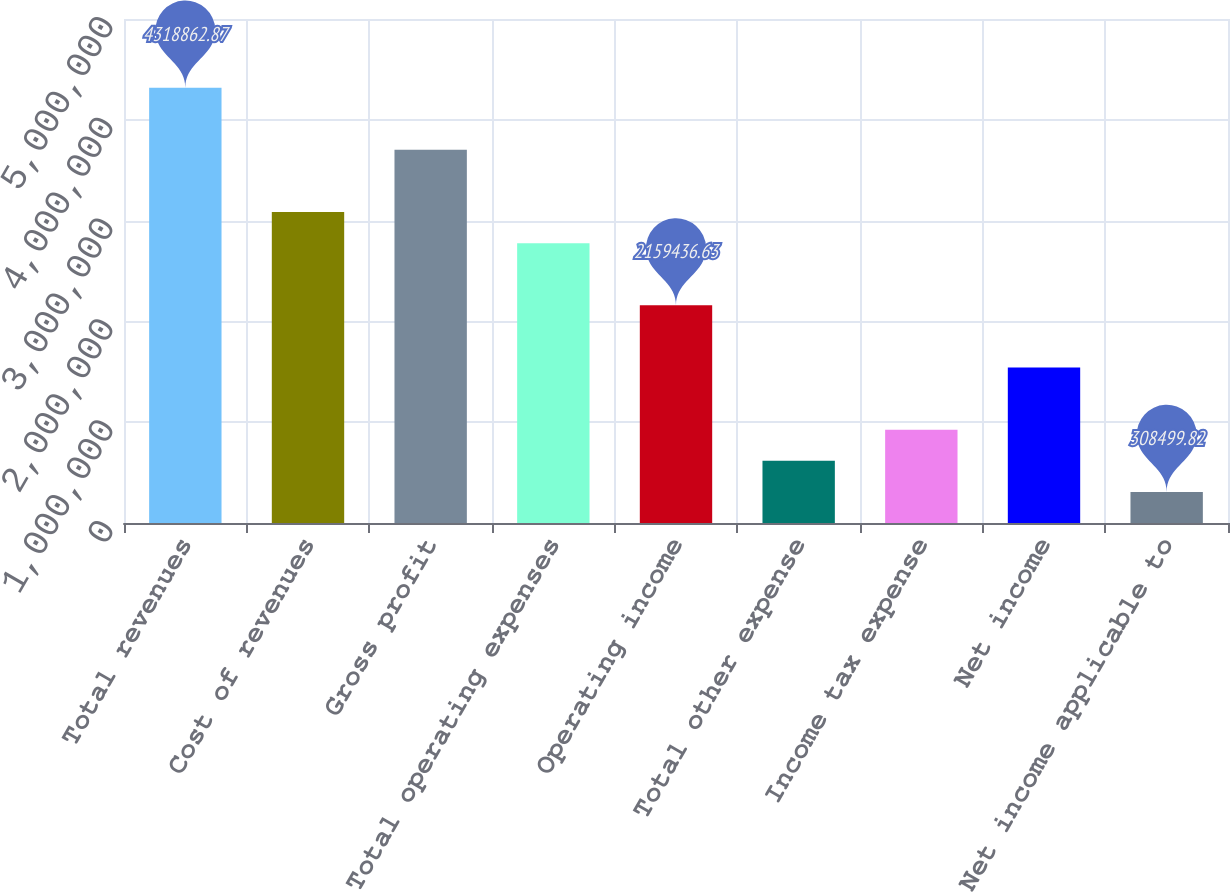<chart> <loc_0><loc_0><loc_500><loc_500><bar_chart><fcel>Total revenues<fcel>Cost of revenues<fcel>Gross profit<fcel>Total operating expenses<fcel>Operating income<fcel>Total other expense<fcel>Income tax expense<fcel>Net income<fcel>Net income applicable to<nl><fcel>4.31886e+06<fcel>3.08491e+06<fcel>3.70188e+06<fcel>2.77642e+06<fcel>2.15944e+06<fcel>616989<fcel>925479<fcel>1.54246e+06<fcel>308500<nl></chart> 